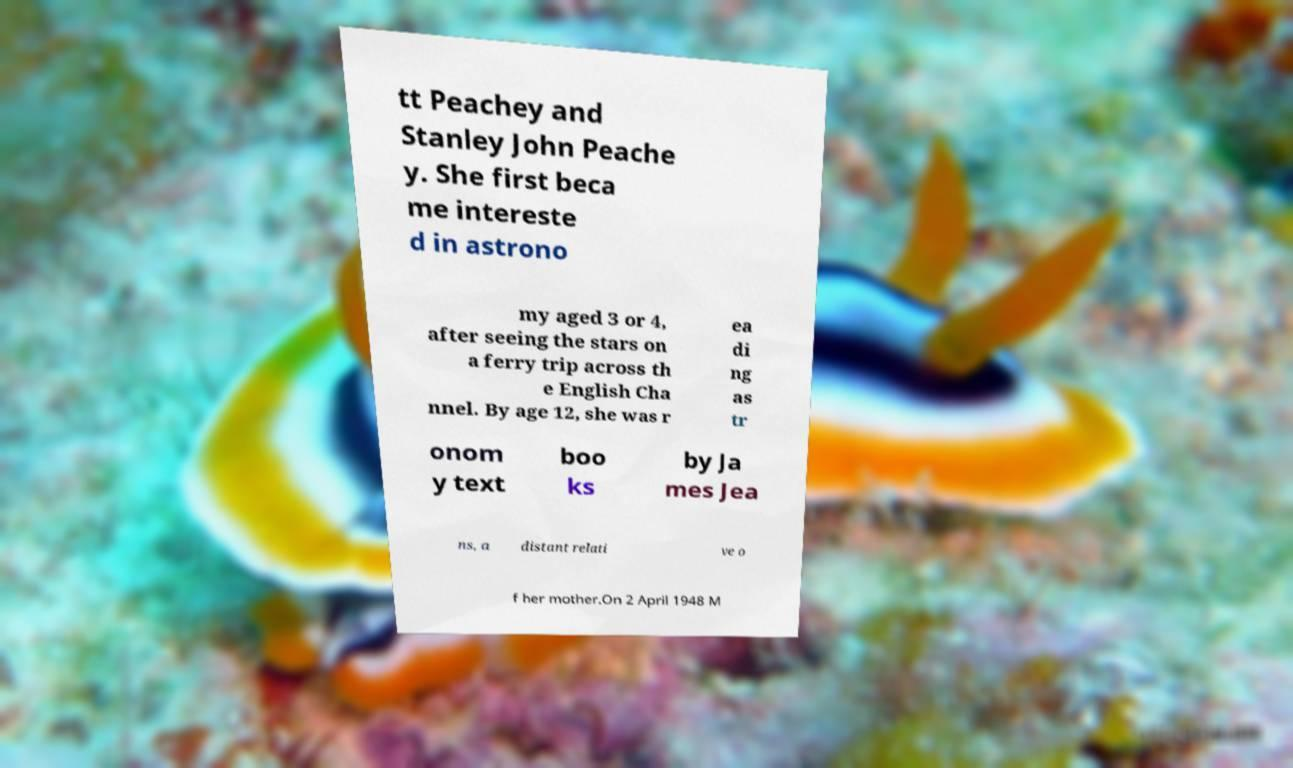There's text embedded in this image that I need extracted. Can you transcribe it verbatim? tt Peachey and Stanley John Peache y. She first beca me intereste d in astrono my aged 3 or 4, after seeing the stars on a ferry trip across th e English Cha nnel. By age 12, she was r ea di ng as tr onom y text boo ks by Ja mes Jea ns, a distant relati ve o f her mother.On 2 April 1948 M 